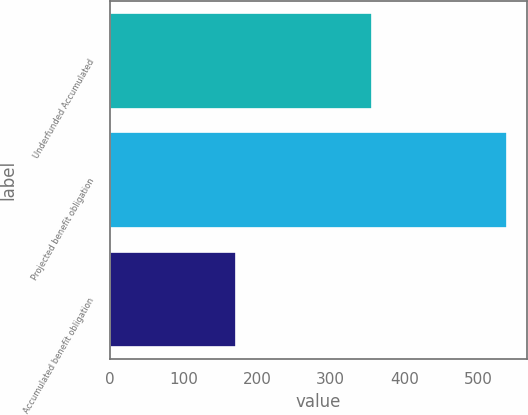Convert chart to OTSL. <chart><loc_0><loc_0><loc_500><loc_500><bar_chart><fcel>Underfunded Accumulated<fcel>Projected benefit obligation<fcel>Accumulated benefit obligation<nl><fcel>355.5<fcel>539<fcel>172<nl></chart> 